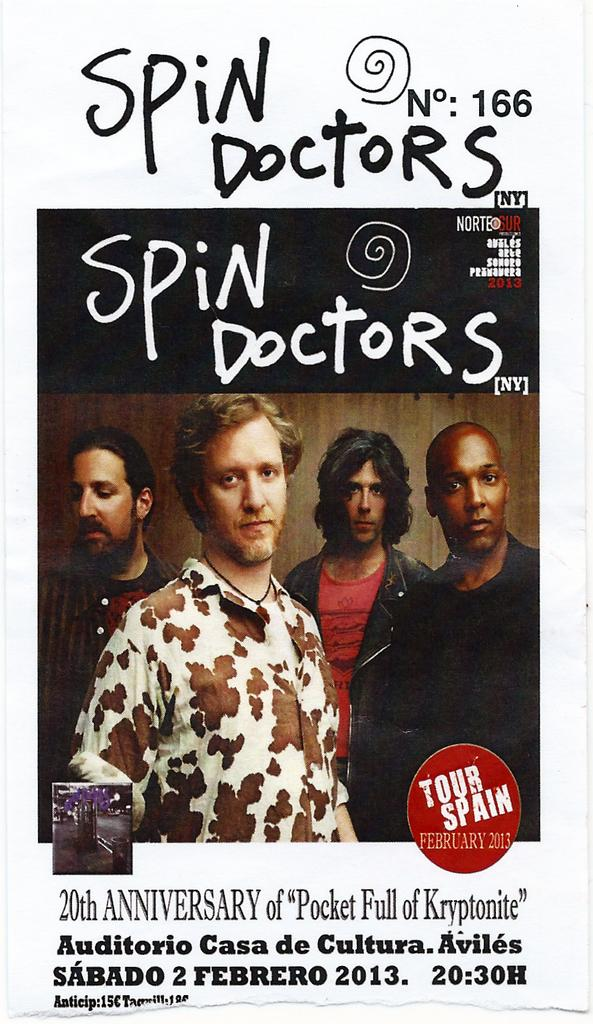<image>
Offer a succinct explanation of the picture presented. A poster for the 20th Anniversary of Pocket Full of Kryptonite. 